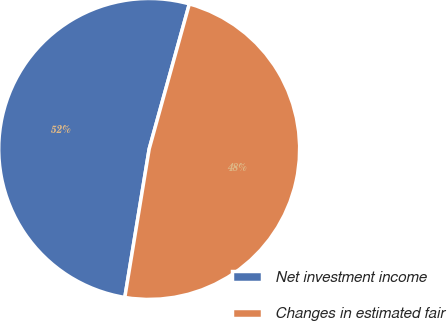<chart> <loc_0><loc_0><loc_500><loc_500><pie_chart><fcel>Net investment income<fcel>Changes in estimated fair<nl><fcel>51.71%<fcel>48.29%<nl></chart> 